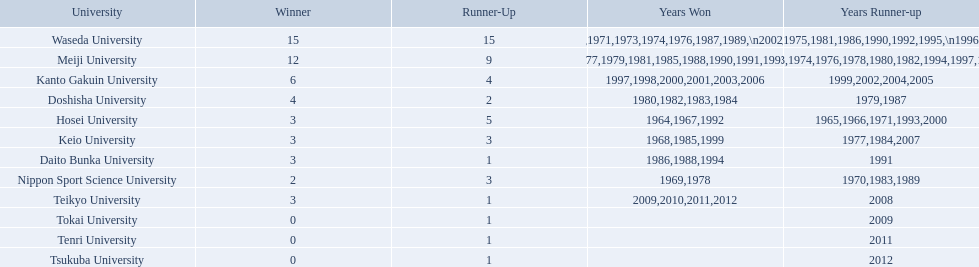What university were there in the all-japan university rugby championship? Waseda University, Meiji University, Kanto Gakuin University, Doshisha University, Hosei University, Keio University, Daito Bunka University, Nippon Sport Science University, Teikyo University, Tokai University, Tenri University, Tsukuba University. Of these who had more than 12 wins? Waseda University. 